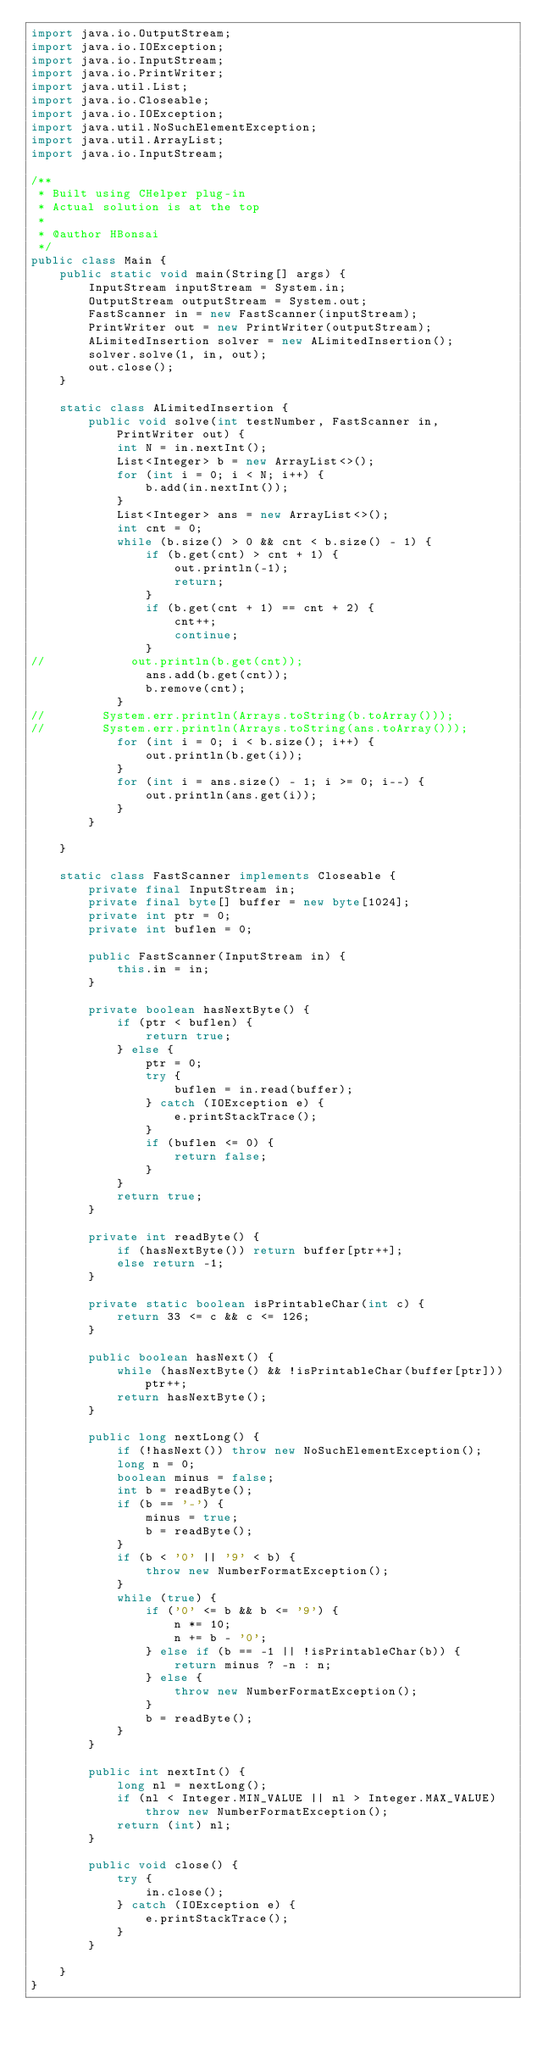Convert code to text. <code><loc_0><loc_0><loc_500><loc_500><_Java_>import java.io.OutputStream;
import java.io.IOException;
import java.io.InputStream;
import java.io.PrintWriter;
import java.util.List;
import java.io.Closeable;
import java.io.IOException;
import java.util.NoSuchElementException;
import java.util.ArrayList;
import java.io.InputStream;

/**
 * Built using CHelper plug-in
 * Actual solution is at the top
 *
 * @author HBonsai
 */
public class Main {
    public static void main(String[] args) {
        InputStream inputStream = System.in;
        OutputStream outputStream = System.out;
        FastScanner in = new FastScanner(inputStream);
        PrintWriter out = new PrintWriter(outputStream);
        ALimitedInsertion solver = new ALimitedInsertion();
        solver.solve(1, in, out);
        out.close();
    }

    static class ALimitedInsertion {
        public void solve(int testNumber, FastScanner in, PrintWriter out) {
            int N = in.nextInt();
            List<Integer> b = new ArrayList<>();
            for (int i = 0; i < N; i++) {
                b.add(in.nextInt());
            }
            List<Integer> ans = new ArrayList<>();
            int cnt = 0;
            while (b.size() > 0 && cnt < b.size() - 1) {
                if (b.get(cnt) > cnt + 1) {
                    out.println(-1);
                    return;
                }
                if (b.get(cnt + 1) == cnt + 2) {
                    cnt++;
                    continue;
                }
//            out.println(b.get(cnt));
                ans.add(b.get(cnt));
                b.remove(cnt);
            }
//        System.err.println(Arrays.toString(b.toArray()));
//        System.err.println(Arrays.toString(ans.toArray()));
            for (int i = 0; i < b.size(); i++) {
                out.println(b.get(i));
            }
            for (int i = ans.size() - 1; i >= 0; i--) {
                out.println(ans.get(i));
            }
        }

    }

    static class FastScanner implements Closeable {
        private final InputStream in;
        private final byte[] buffer = new byte[1024];
        private int ptr = 0;
        private int buflen = 0;

        public FastScanner(InputStream in) {
            this.in = in;
        }

        private boolean hasNextByte() {
            if (ptr < buflen) {
                return true;
            } else {
                ptr = 0;
                try {
                    buflen = in.read(buffer);
                } catch (IOException e) {
                    e.printStackTrace();
                }
                if (buflen <= 0) {
                    return false;
                }
            }
            return true;
        }

        private int readByte() {
            if (hasNextByte()) return buffer[ptr++];
            else return -1;
        }

        private static boolean isPrintableChar(int c) {
            return 33 <= c && c <= 126;
        }

        public boolean hasNext() {
            while (hasNextByte() && !isPrintableChar(buffer[ptr])) ptr++;
            return hasNextByte();
        }

        public long nextLong() {
            if (!hasNext()) throw new NoSuchElementException();
            long n = 0;
            boolean minus = false;
            int b = readByte();
            if (b == '-') {
                minus = true;
                b = readByte();
            }
            if (b < '0' || '9' < b) {
                throw new NumberFormatException();
            }
            while (true) {
                if ('0' <= b && b <= '9') {
                    n *= 10;
                    n += b - '0';
                } else if (b == -1 || !isPrintableChar(b)) {
                    return minus ? -n : n;
                } else {
                    throw new NumberFormatException();
                }
                b = readByte();
            }
        }

        public int nextInt() {
            long nl = nextLong();
            if (nl < Integer.MIN_VALUE || nl > Integer.MAX_VALUE) throw new NumberFormatException();
            return (int) nl;
        }

        public void close() {
            try {
                in.close();
            } catch (IOException e) {
                e.printStackTrace();
            }
        }

    }
}

</code> 